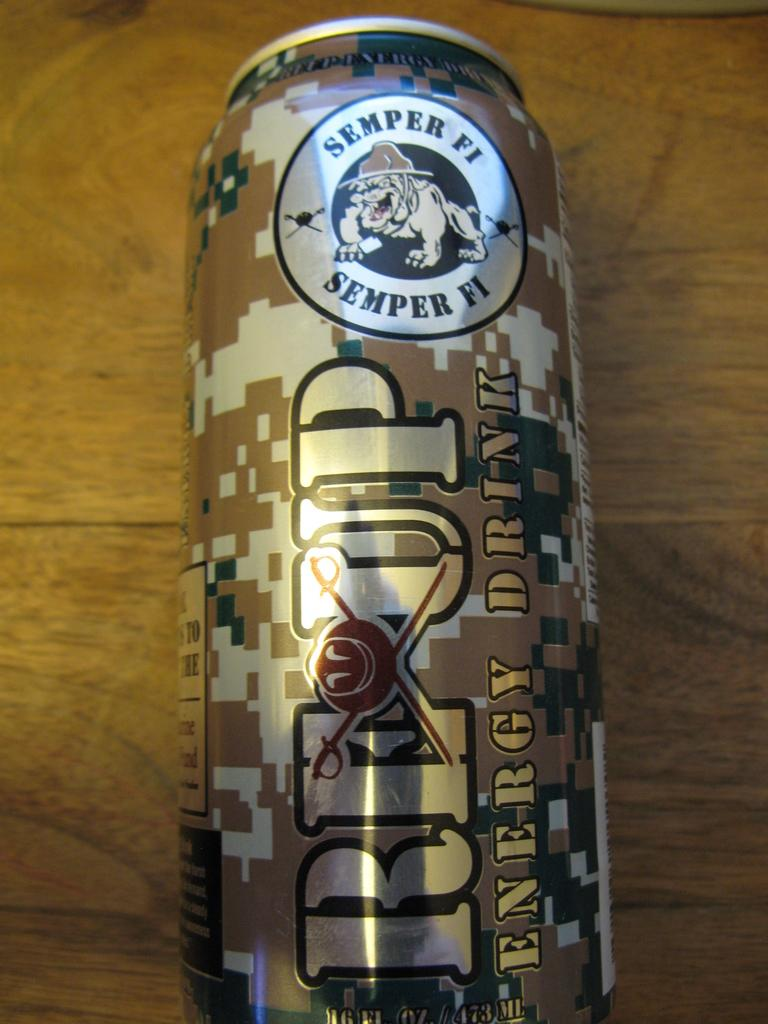<image>
Provide a brief description of the given image. A camouflaged can of re up energy drink wit hthe word semper fi on the top. 